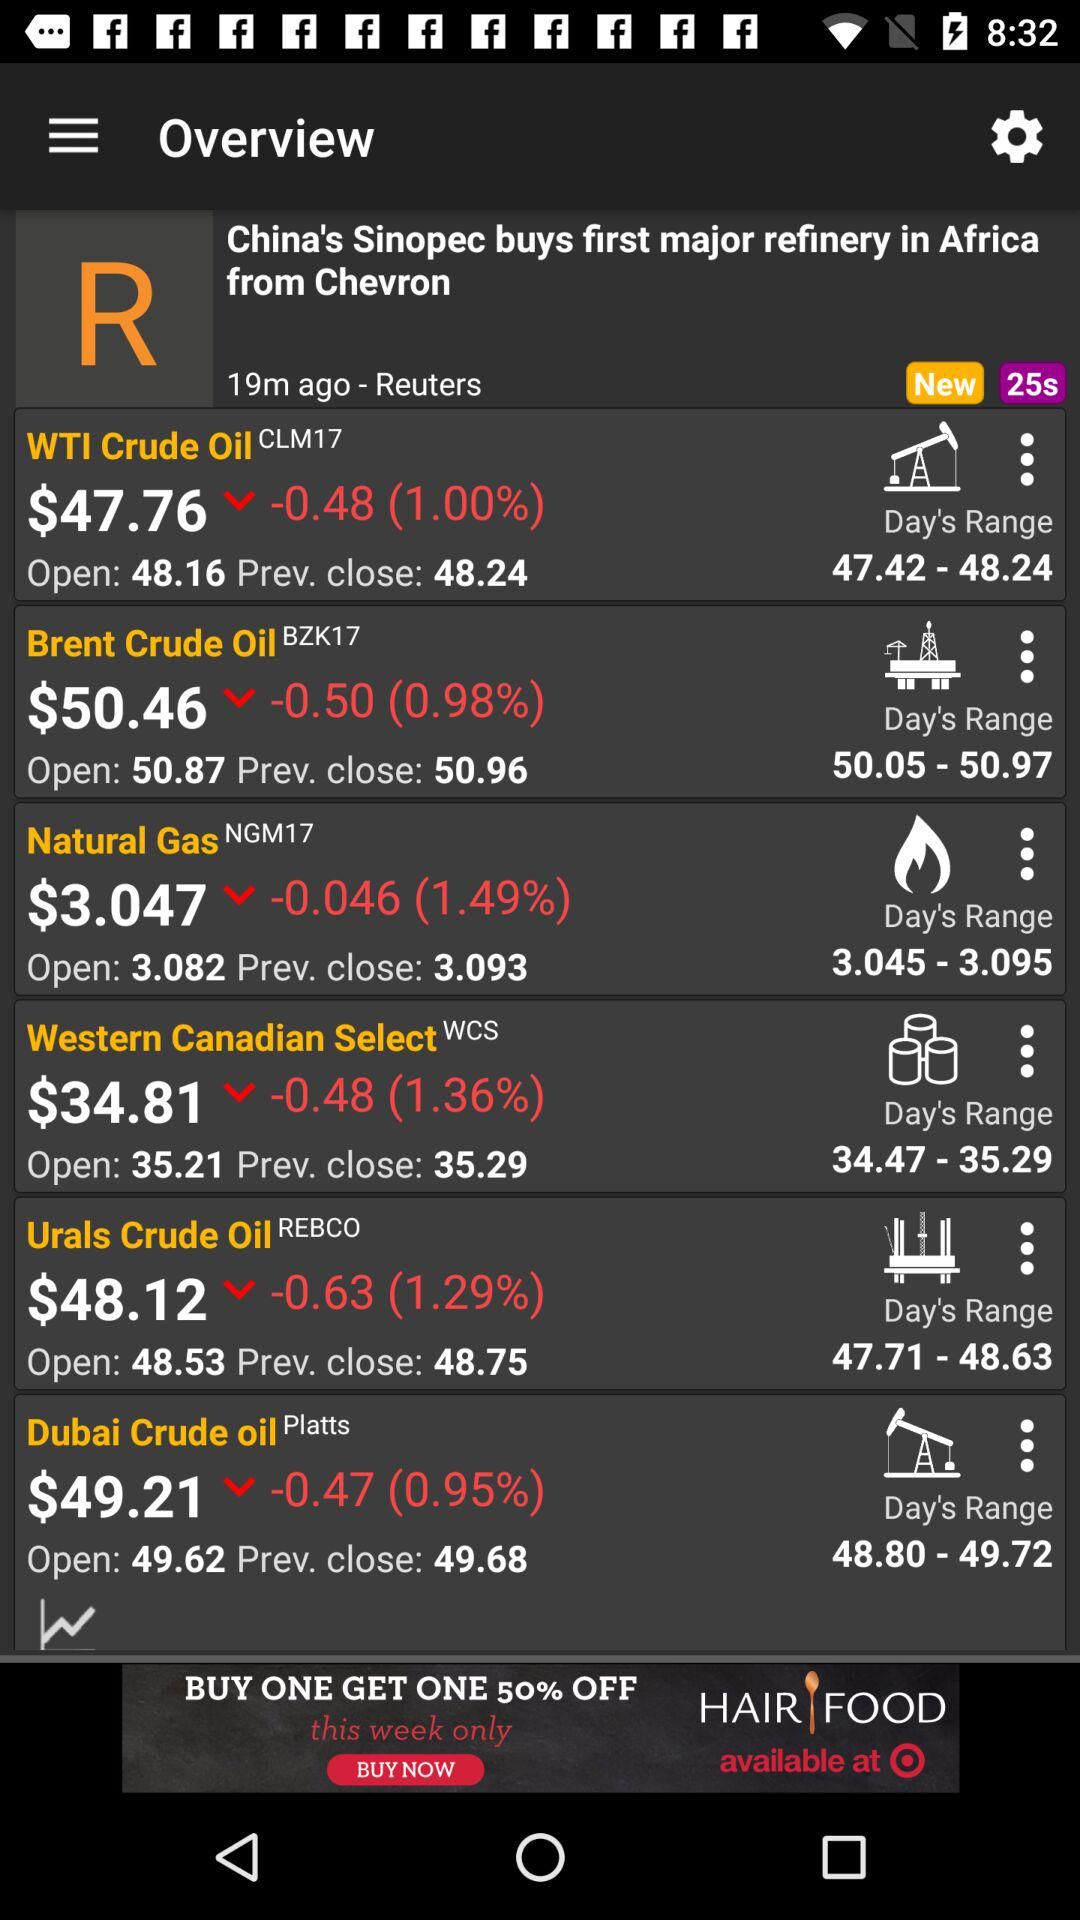What is the previous close price for "WTI Crude Oil" stock? The previous close price is $48.24. 